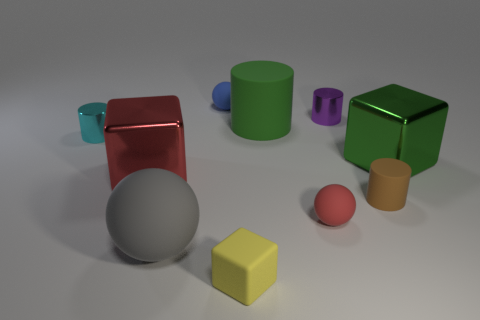There is a tiny metallic cylinder on the right side of the small metallic object to the left of the yellow block; are there any things that are on the right side of it?
Give a very brief answer. Yes. How many large objects are gray matte objects or green matte objects?
Your answer should be compact. 2. Are there any other things of the same color as the large cylinder?
Keep it short and to the point. Yes. There is a metallic cube left of the purple object; does it have the same size as the green cylinder?
Offer a very short reply. Yes. There is a large metal cube that is right of the matte thing behind the big rubber object that is behind the small cyan shiny object; what color is it?
Your response must be concise. Green. The big cylinder is what color?
Make the answer very short. Green. Is the material of the cylinder that is behind the large matte cylinder the same as the big gray sphere in front of the green matte thing?
Give a very brief answer. No. There is another tiny object that is the same shape as the blue rubber thing; what material is it?
Provide a succinct answer. Rubber. Is the material of the big green block the same as the large green cylinder?
Ensure brevity in your answer.  No. What is the color of the matte sphere that is behind the large shiny thing on the right side of the small yellow thing?
Provide a succinct answer. Blue. 